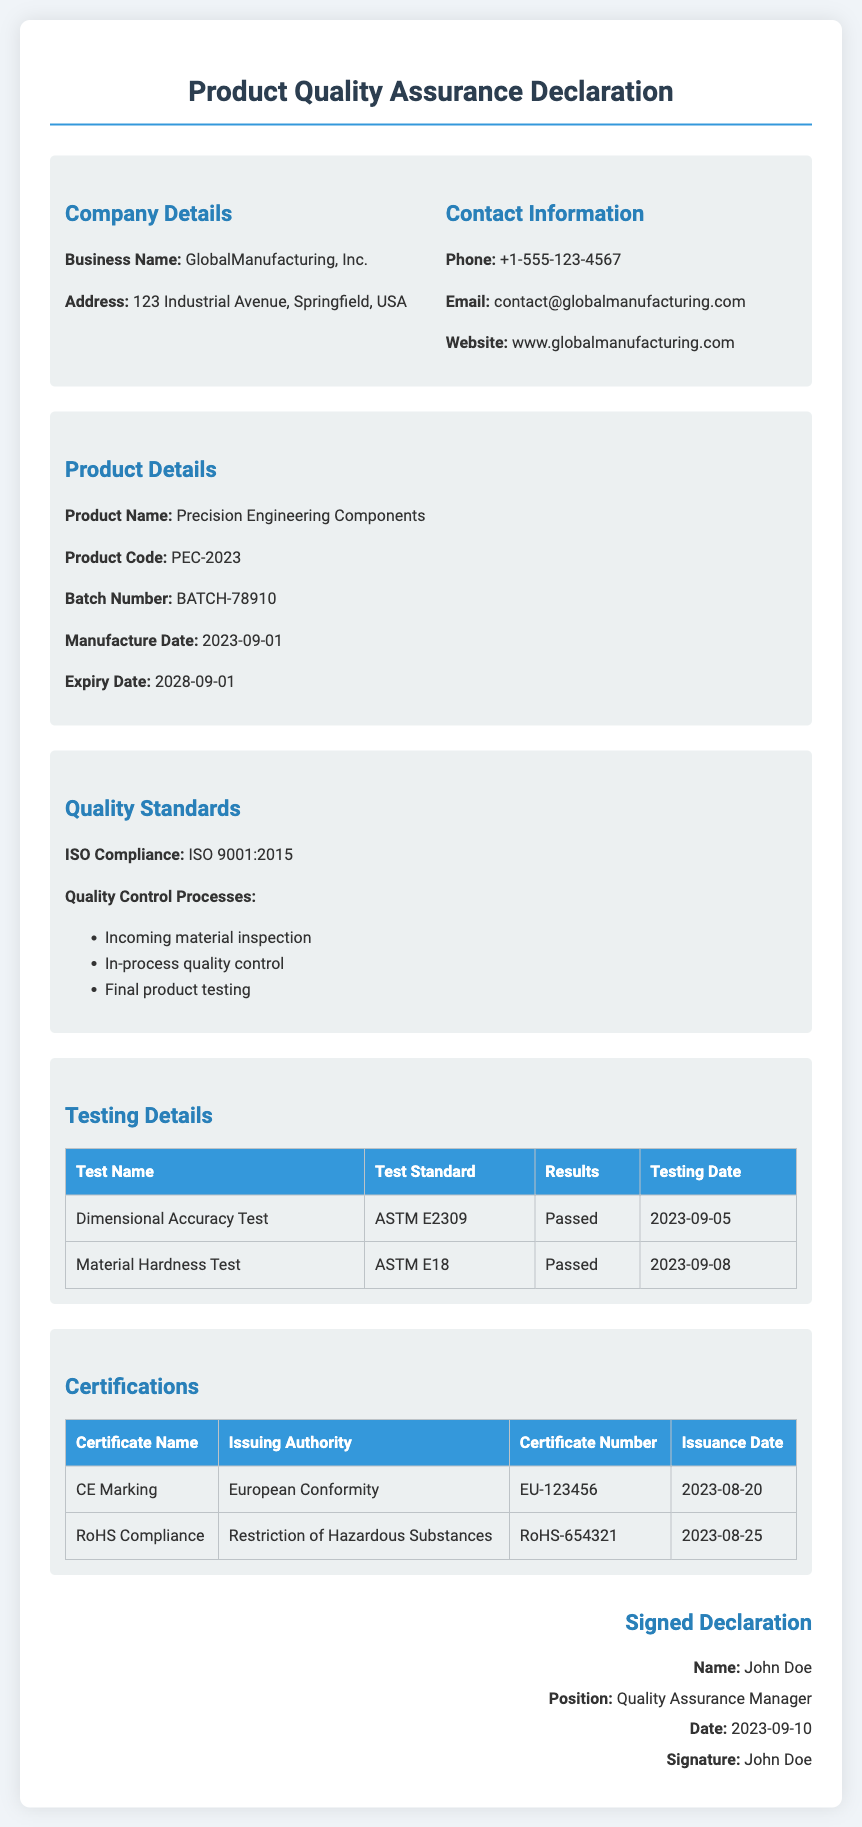What is the business name? The business name is specified in the company details section.
Answer: GlobalManufacturing, Inc What is the product code? The product code is indicated under the product details section.
Answer: PEC-2023 When was the manufacture date? The manufacture date is mentioned in the product details section.
Answer: 2023-09-01 What ISO standard does the product comply with? The ISO compliance section specifies the standard the product adheres to.
Answer: ISO 9001:2015 Who is the quality assurance manager? The name of the quality assurance manager is found in the signed declaration section.
Answer: John Doe What was the result of the dimensional accuracy test? The result is included in the testing details table.
Answer: Passed What is the certificate number for CE marking? The certificate number is detailed in the certifications table.
Answer: EU-123456 How many quality control processes are listed? The quality control processes are outlined in the quality standards section.
Answer: Three When was the signature date on the declaration? The signature date is recorded in the signed declaration section.
Answer: 2023-09-10 